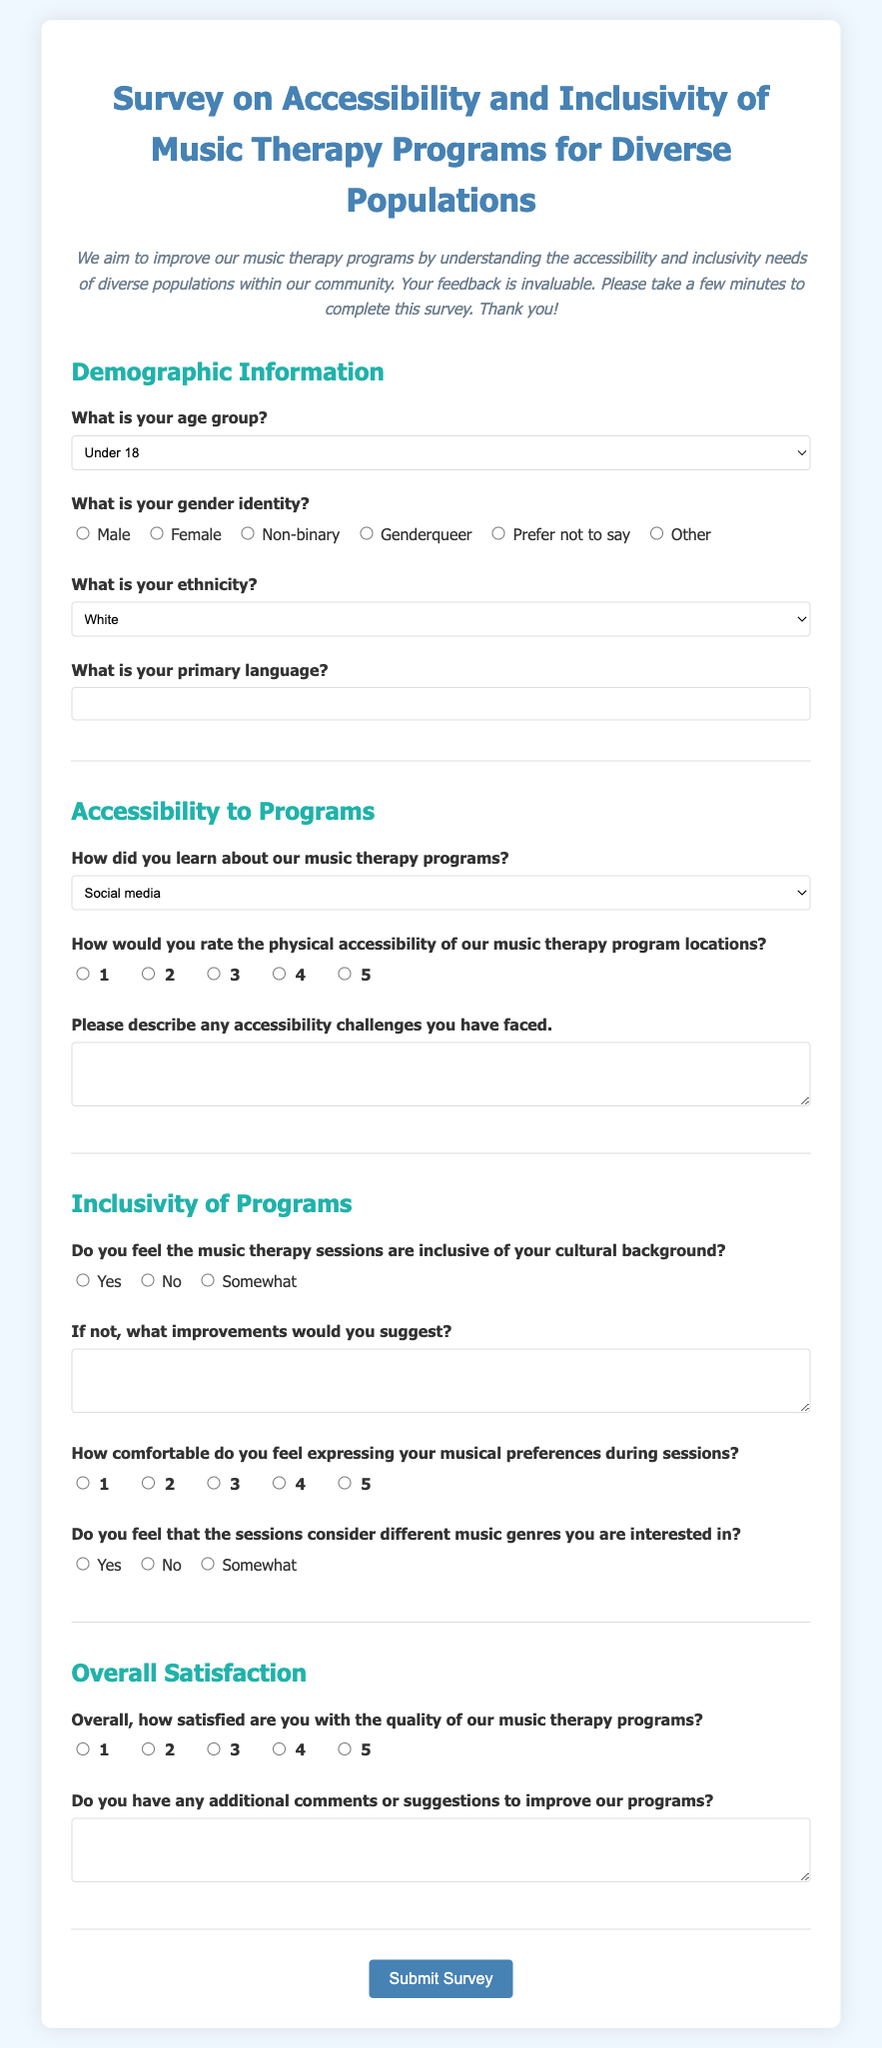What is the title of the survey? The title of the survey is located in the header section of the document.
Answer: Survey on Accessibility and Inclusivity of Music Therapy Programs for Diverse Populations What is the primary language question asking for? The question about primary language is meant to gather information about the respondents' preferred communication language.
Answer: Primary language How many age group options are provided? The age group options can be counted directly from the selection provided in the form.
Answer: Seven What is the highest rating available for physical accessibility? The highest rating is indicated in the rating question regarding physical accessibility.
Answer: 5 What type of feedback does the session inclusivity question seek? The inclusivity question seeks to understand how well the therapy sessions reflect the cultural backgrounds of the respondents.
Answer: Cultural background What type of information is requested in the final question of the survey? The final question is looking for additional comments or suggestions for improvement regarding the music therapy programs.
Answer: Additional comments How is the comfort level of expressing musical preferences measured? The comfort level is measured using a scale of 1 to 5 provided in the rating section.
Answer: 1 to 5 Which demographic information is not explicitly asked for in the survey? Information such as personal income or education level is not mentioned in the demographic questions.
Answer: Income or education level 